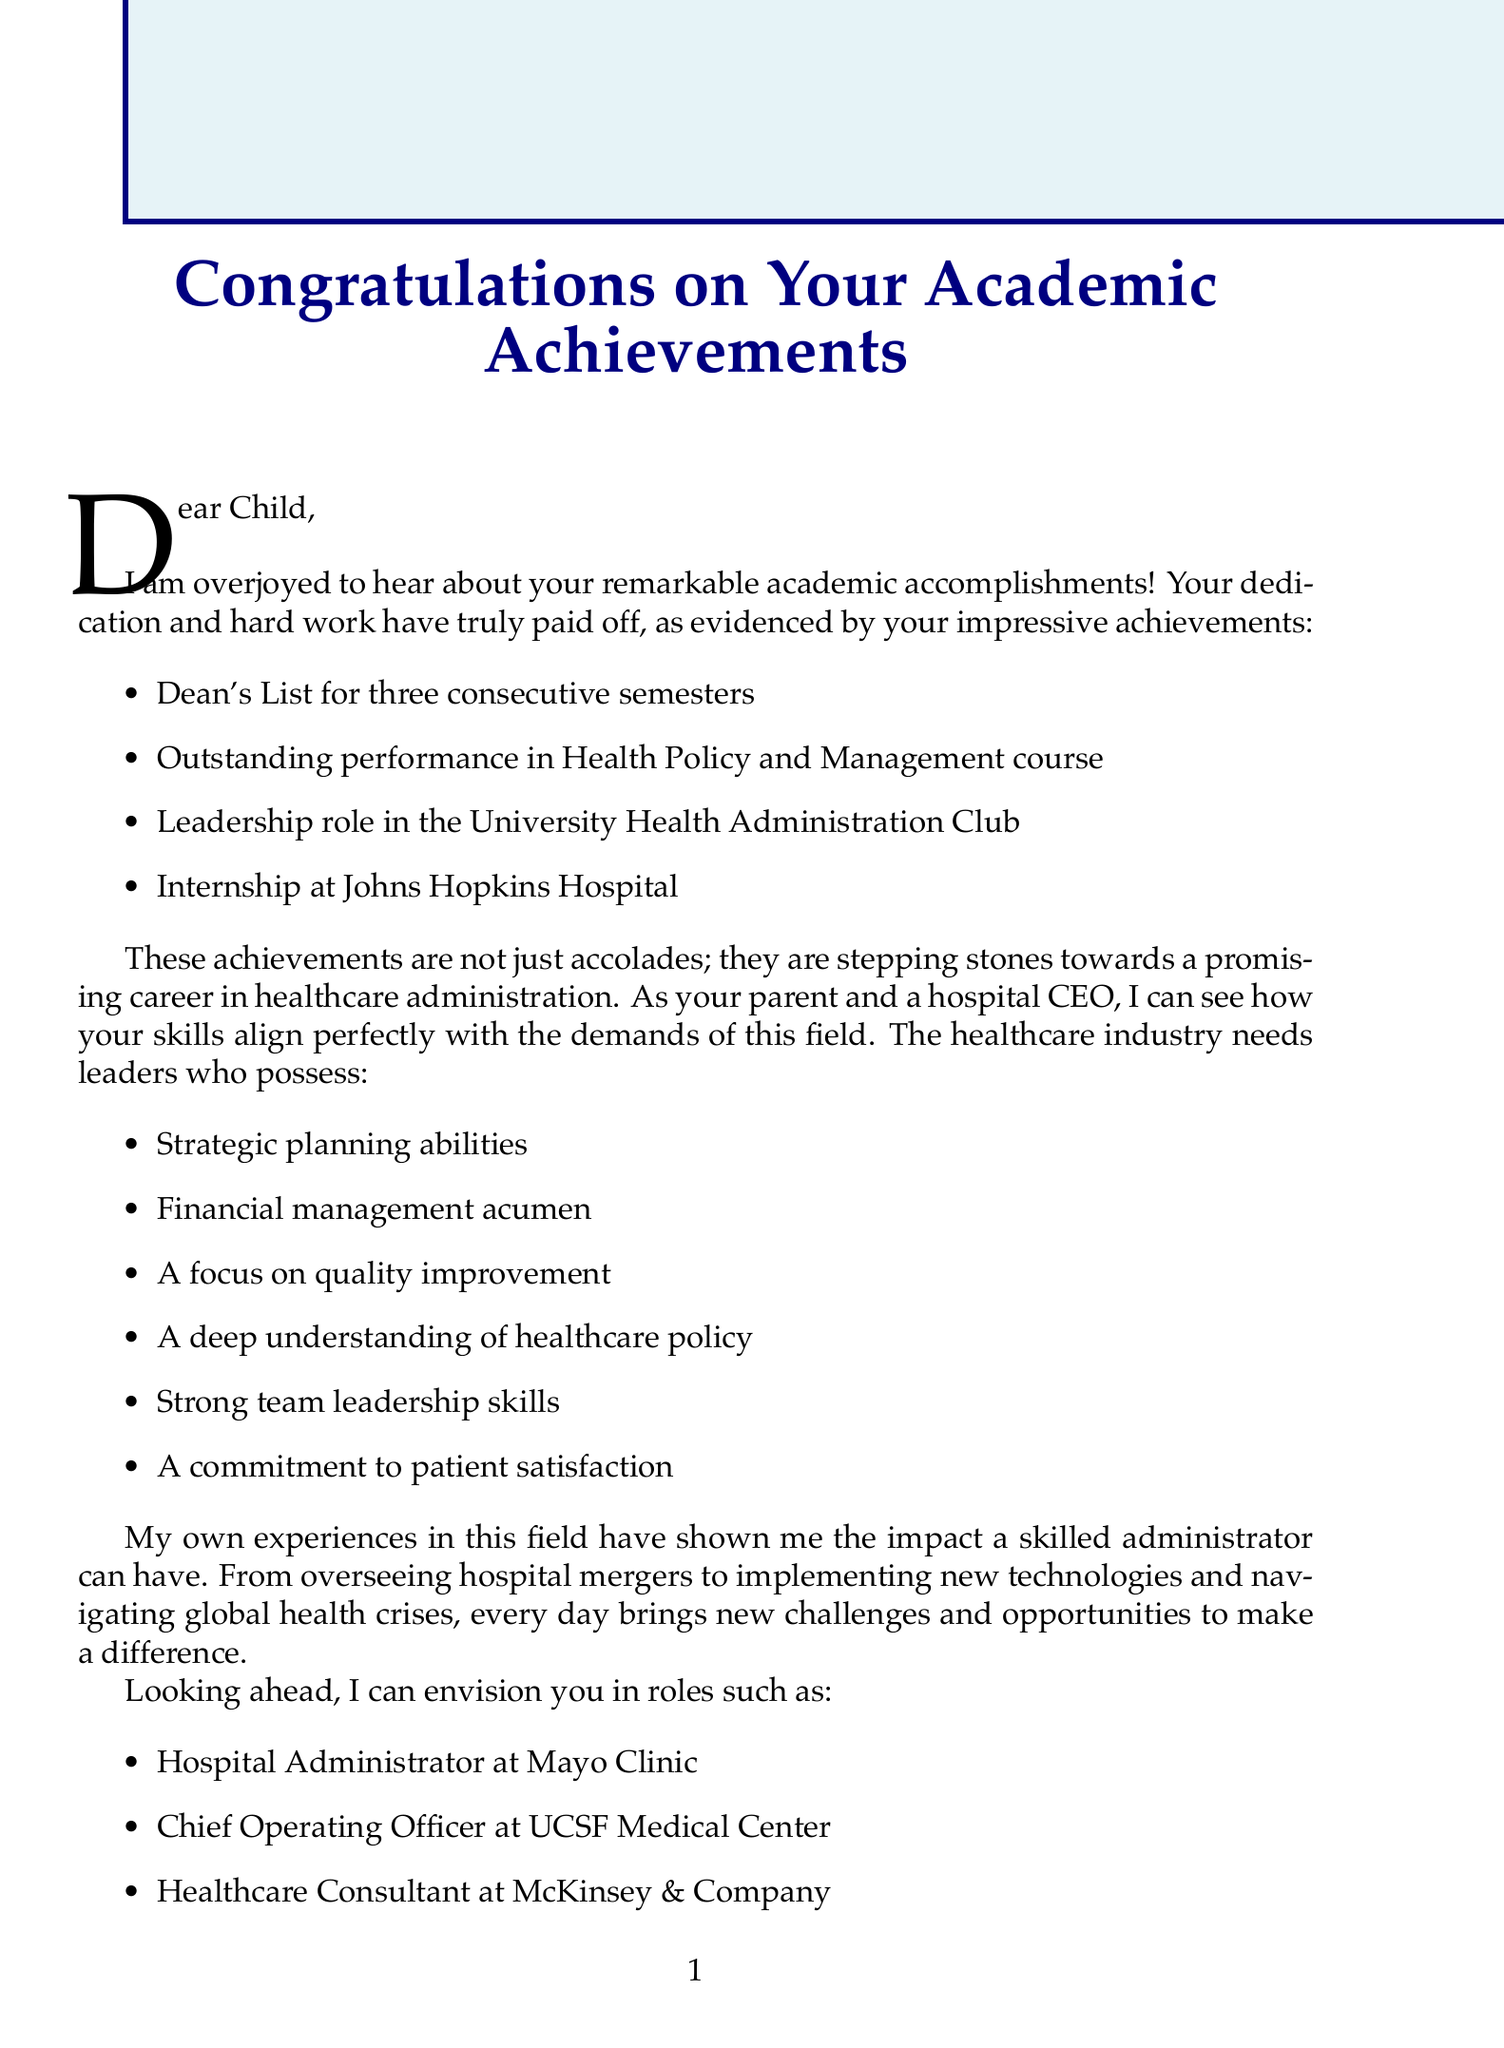What is the title of the letter? The title is prominently displayed at the beginning of the letter and highlights the overall purpose.
Answer: Congratulations on Your Academic Achievements How many semesters did the child make the Dean's List? The document states the specific duration the child achieved this honor.
Answer: three Which course did the child perform outstandingly in? The letter specifically identifies a course where the child excelled academically.
Answer: Health Policy and Management course What leadership role did the child have? The letter mentions a particular role that showcases the child's leadership skills.
Answer: University Health Administration Club What is one of the future roles mentioned for the child? The letter suggests potential career paths, and one is specifically highlighted among the options.
Answer: Hospital Administrator at Mayo Clinic What kind of skill related to healthcare administration is highlighted in the letter? The document lists important skills required for healthcare administration, emphasizing the skills the child possesses.
Answer: Strategic planning What notable experience does the parent share as a hospital CEO? The parent recounts a significant professional experience that relates to their position and importance in healthcare.
Answer: Overseeing the merger of St. Mary's Hospital and Regional Medical Center Which organization is recommended for engagement by the child? The document suggests an organization that would be beneficial for the child's career development in healthcare.
Answer: American College of Healthcare Executives What is the parent's sentiment towards the child's achievements? The letter expresses a strong emotional viewpoint regarding the child's accomplishments.
Answer: Proud 